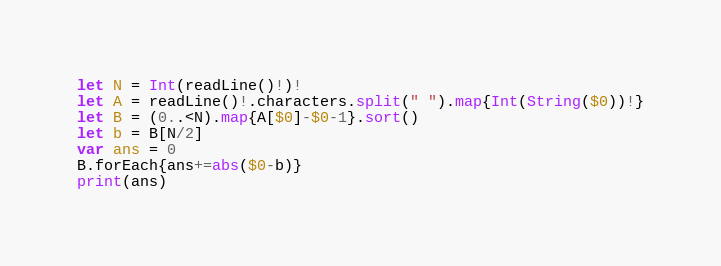Convert code to text. <code><loc_0><loc_0><loc_500><loc_500><_Swift_>let N = Int(readLine()!)!
let A = readLine()!.characters.split(" ").map{Int(String($0))!}
let B = (0..<N).map{A[$0]-$0-1}.sort()
let b = B[N/2]
var ans = 0
B.forEach{ans+=abs($0-b)}
print(ans)</code> 